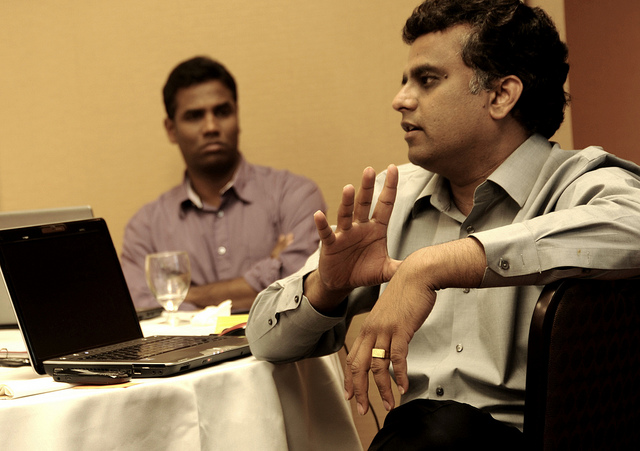<image>Why is the other man mad? I don't know why the other man is mad. It might be because he disagrees or is bored. Why is the other man mad? I don't know why the other man is mad. It can be because he disagrees with something or he is not happy. 